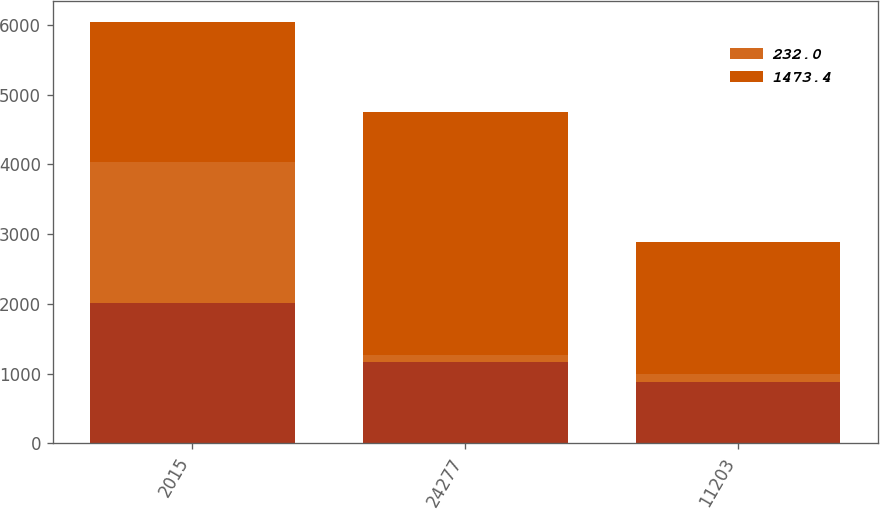Convert chart. <chart><loc_0><loc_0><loc_500><loc_500><stacked_bar_chart><ecel><fcel>2015<fcel>24277<fcel>11203<nl><fcel>nan<fcel>2015<fcel>1163.4<fcel>883.9<nl><fcel>232<fcel>2015<fcel>106.6<fcel>106.6<nl><fcel>1473.4<fcel>2015<fcel>3484.5<fcel>1897.6<nl></chart> 